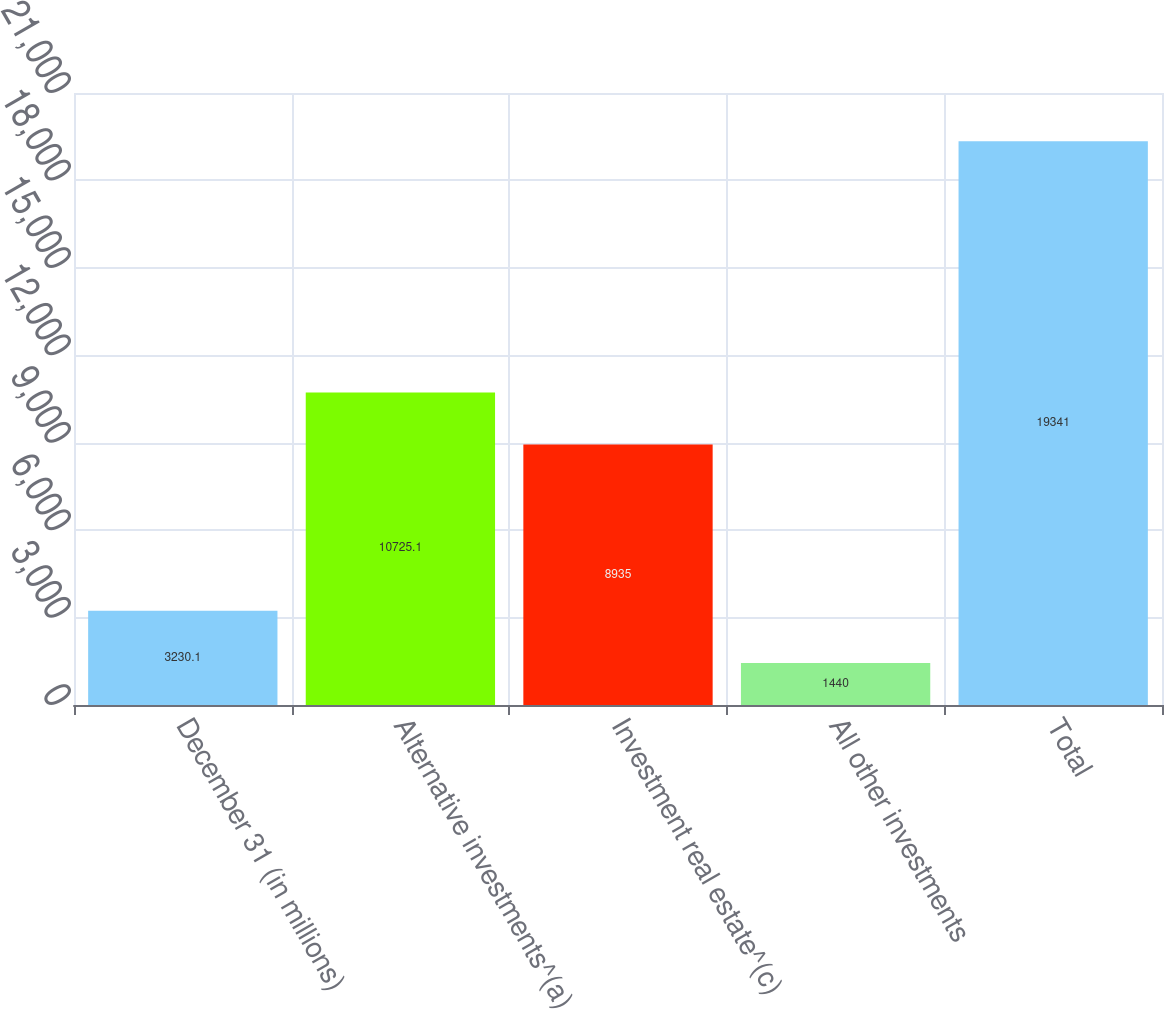Convert chart to OTSL. <chart><loc_0><loc_0><loc_500><loc_500><bar_chart><fcel>December 31 (in millions)<fcel>Alternative investments^(a)<fcel>Investment real estate^(c)<fcel>All other investments<fcel>Total<nl><fcel>3230.1<fcel>10725.1<fcel>8935<fcel>1440<fcel>19341<nl></chart> 